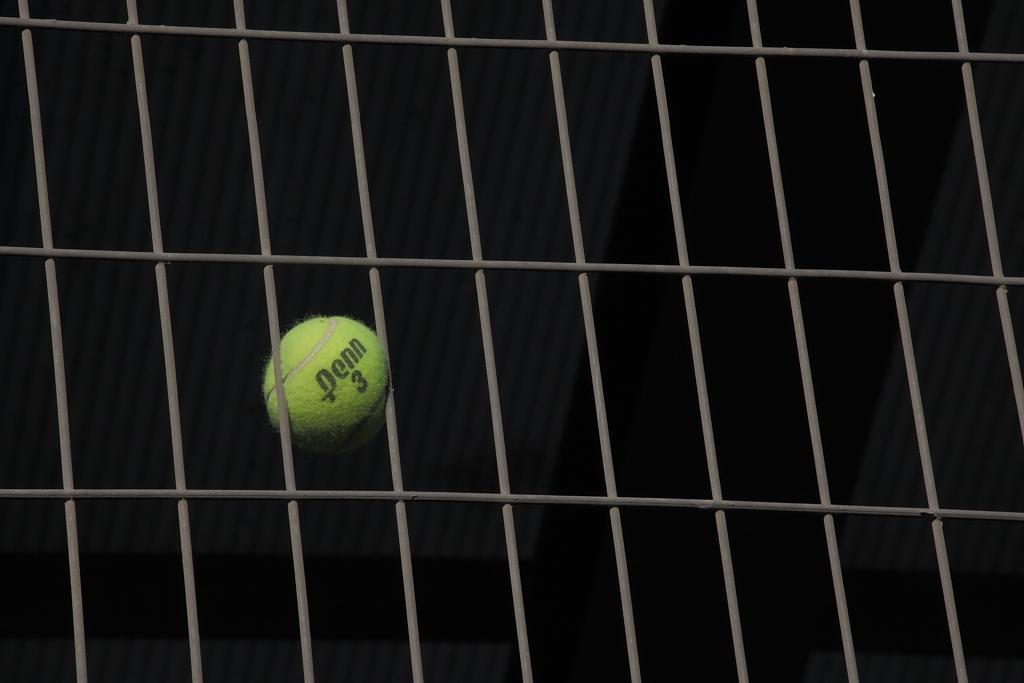Describe this image in one or two sentences. In this image, I can see a tennis ball. I think this is a kind of fencing sheet. The background looks dark. 